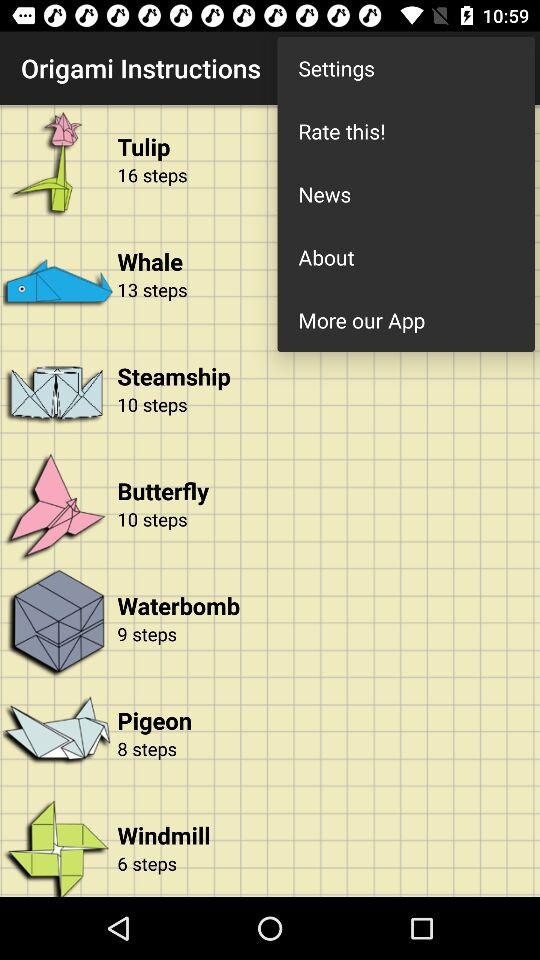How many more steps does the windmill have than the pigeon?
Answer the question using a single word or phrase. 2 